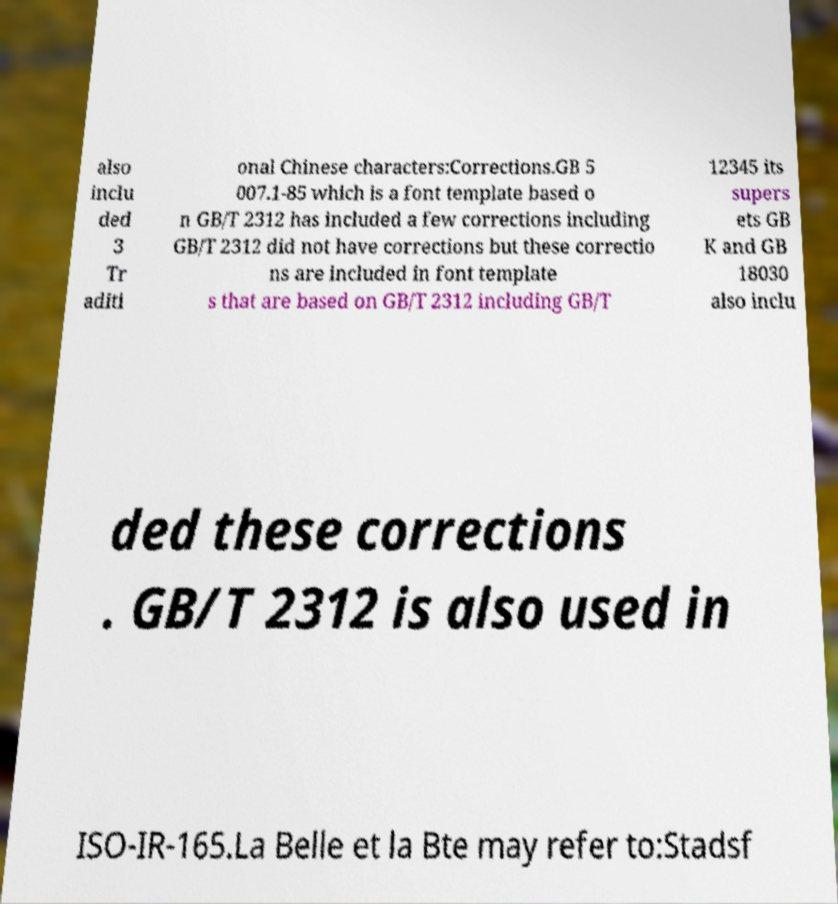What messages or text are displayed in this image? I need them in a readable, typed format. also inclu ded 3 Tr aditi onal Chinese characters:Corrections.GB 5 007.1-85 which is a font template based o n GB/T 2312 has included a few corrections including GB/T 2312 did not have corrections but these correctio ns are included in font template s that are based on GB/T 2312 including GB/T 12345 its supers ets GB K and GB 18030 also inclu ded these corrections . GB/T 2312 is also used in ISO-IR-165.La Belle et la Bte may refer to:Stadsf 